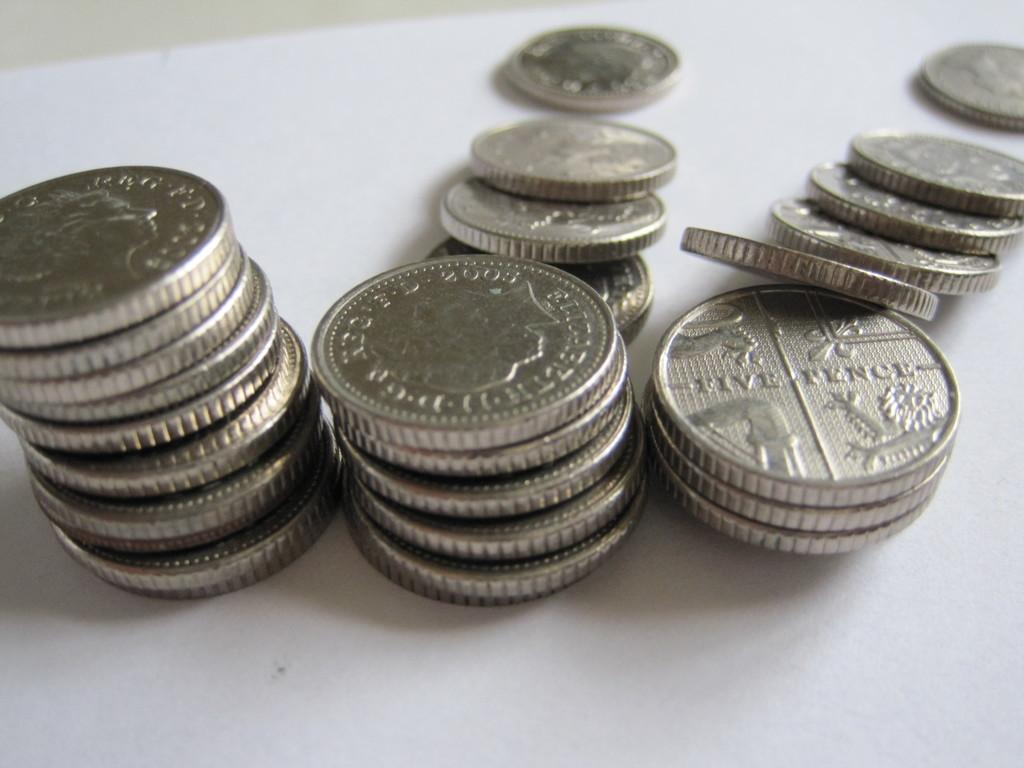<image>
Provide a brief description of the given image. Three stacks of silver coins one says five pence on it. 